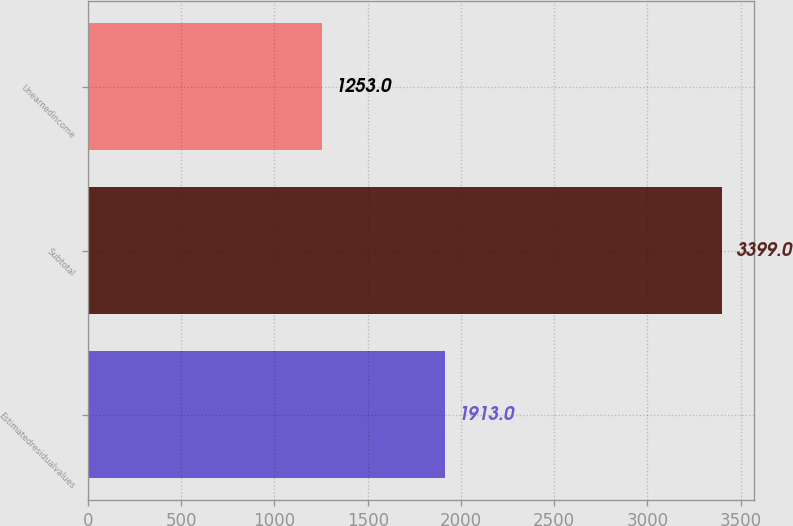<chart> <loc_0><loc_0><loc_500><loc_500><bar_chart><fcel>Estimatedresidualvalues<fcel>Subtotal<fcel>Unearnedincome<nl><fcel>1913<fcel>3399<fcel>1253<nl></chart> 